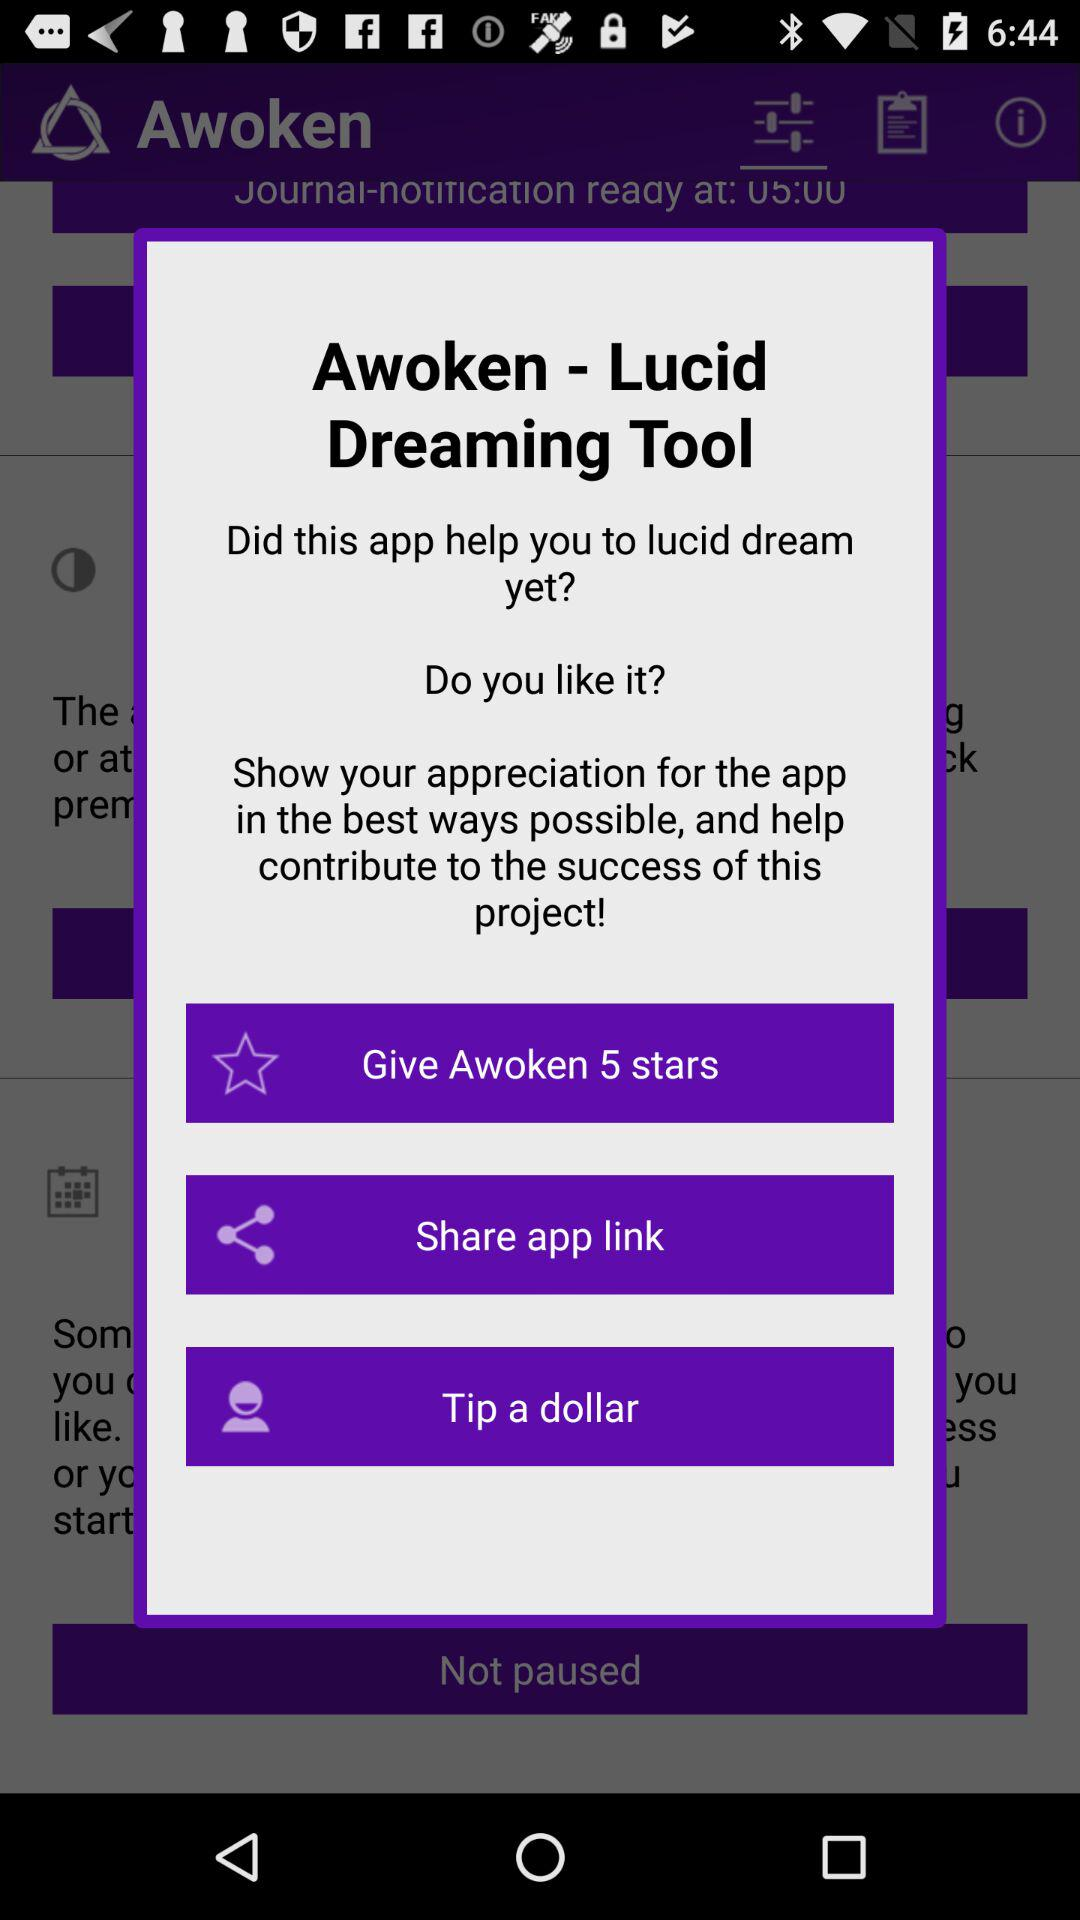What is the name of the application? The name of the application is "Awoken - Lucid Dreaming Tool". 